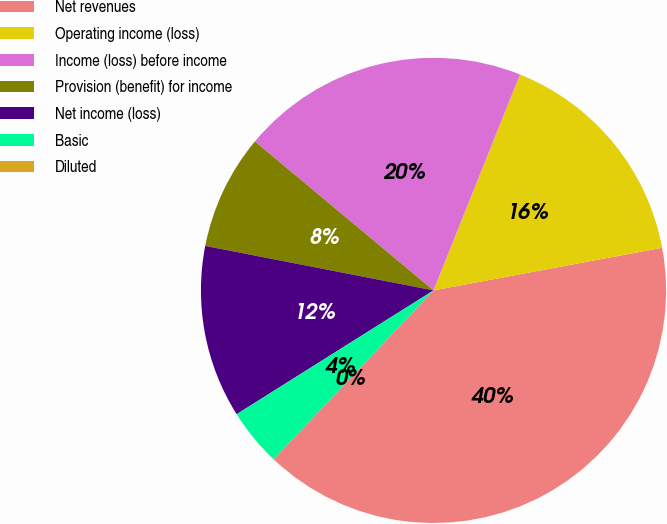Convert chart. <chart><loc_0><loc_0><loc_500><loc_500><pie_chart><fcel>Net revenues<fcel>Operating income (loss)<fcel>Income (loss) before income<fcel>Provision (benefit) for income<fcel>Net income (loss)<fcel>Basic<fcel>Diluted<nl><fcel>40.0%<fcel>16.0%<fcel>20.0%<fcel>8.0%<fcel>12.0%<fcel>4.0%<fcel>0.0%<nl></chart> 